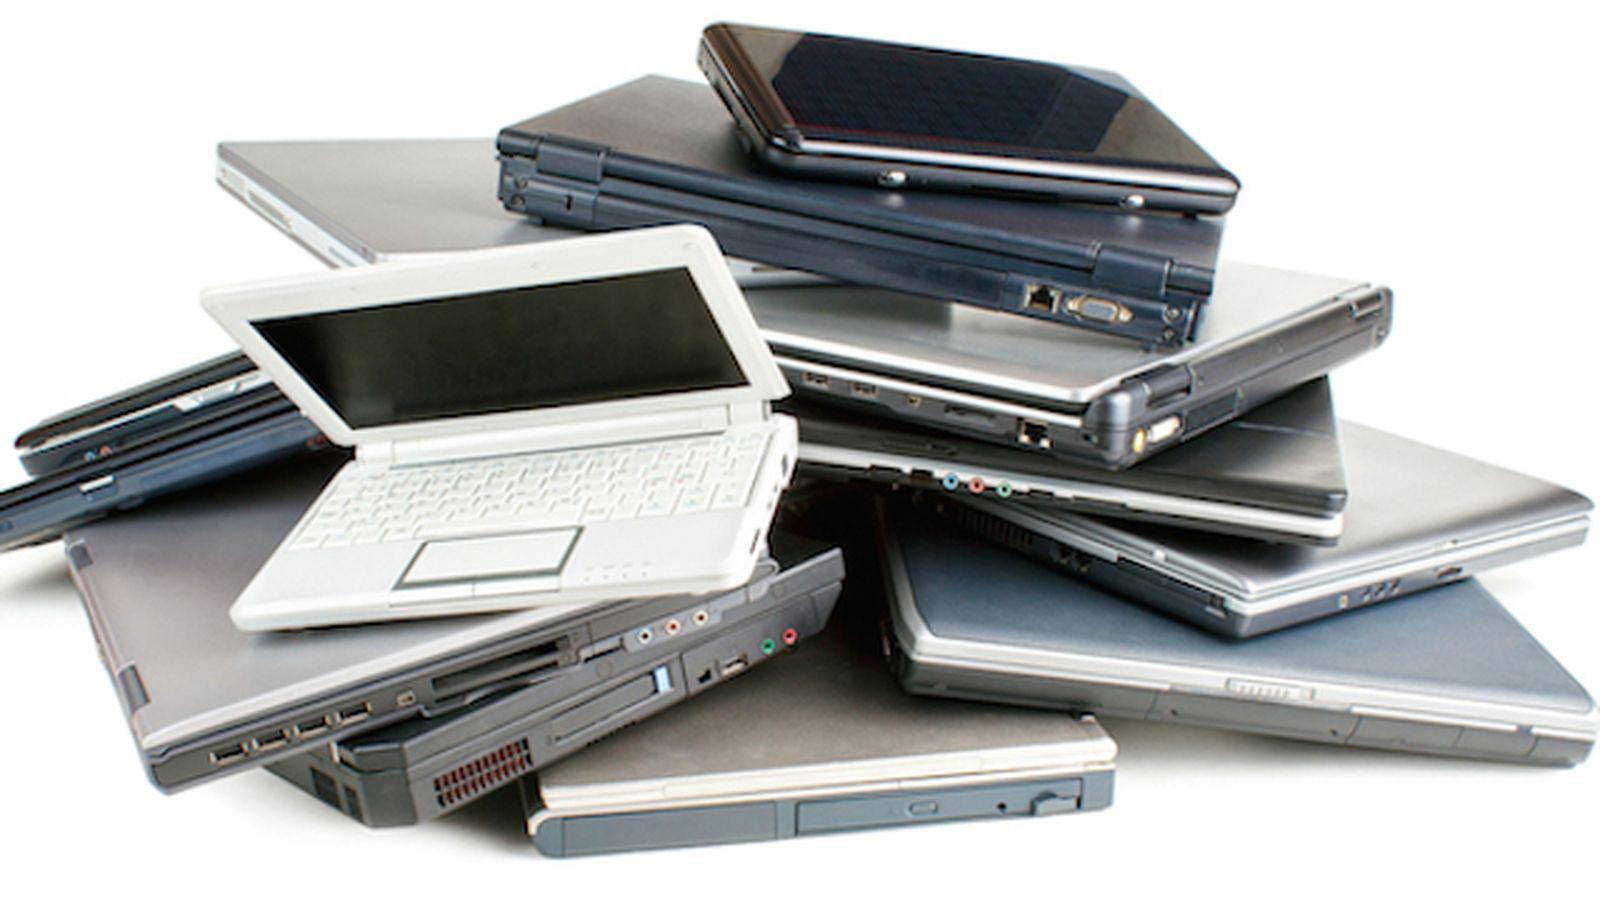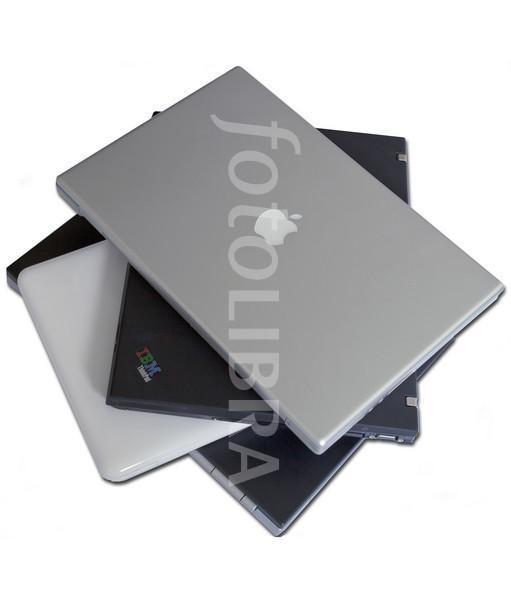The first image is the image on the left, the second image is the image on the right. For the images displayed, is the sentence "there is a pile of laptops in the image on the left, and all visible screens are dark" factually correct? Answer yes or no. Yes. The first image is the image on the left, the second image is the image on the right. Evaluate the accuracy of this statement regarding the images: "There is a black laptop that is opened.". Is it true? Answer yes or no. No. 